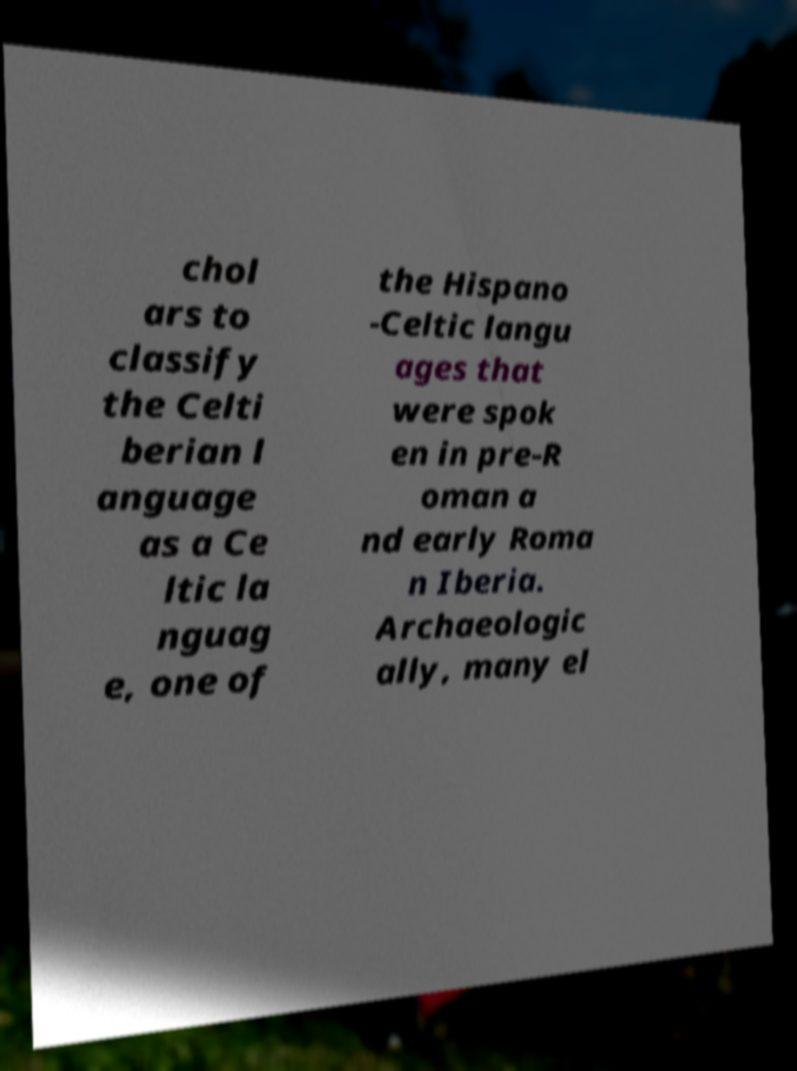There's text embedded in this image that I need extracted. Can you transcribe it verbatim? chol ars to classify the Celti berian l anguage as a Ce ltic la nguag e, one of the Hispano -Celtic langu ages that were spok en in pre-R oman a nd early Roma n Iberia. Archaeologic ally, many el 